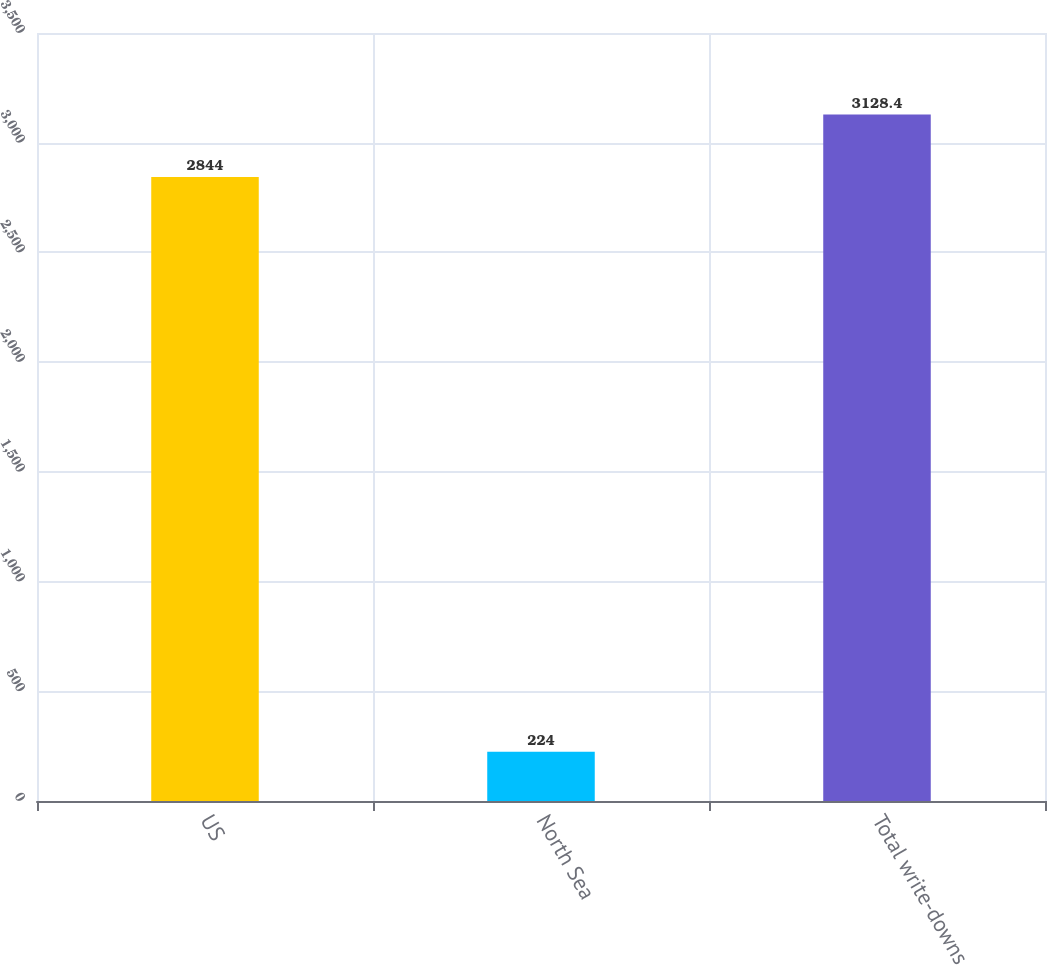<chart> <loc_0><loc_0><loc_500><loc_500><bar_chart><fcel>US<fcel>North Sea<fcel>Total write-downs<nl><fcel>2844<fcel>224<fcel>3128.4<nl></chart> 